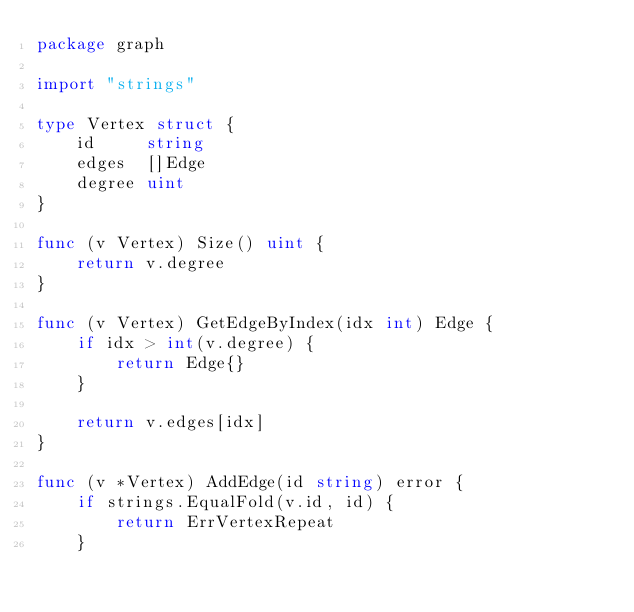Convert code to text. <code><loc_0><loc_0><loc_500><loc_500><_Go_>package graph

import "strings"

type Vertex struct {
	id     string
	edges  []Edge
	degree uint
}

func (v Vertex) Size() uint {
	return v.degree
}

func (v Vertex) GetEdgeByIndex(idx int) Edge {
	if idx > int(v.degree) {
		return Edge{}
	}

	return v.edges[idx]
}

func (v *Vertex) AddEdge(id string) error {
	if strings.EqualFold(v.id, id) {
		return ErrVertexRepeat
	}</code> 